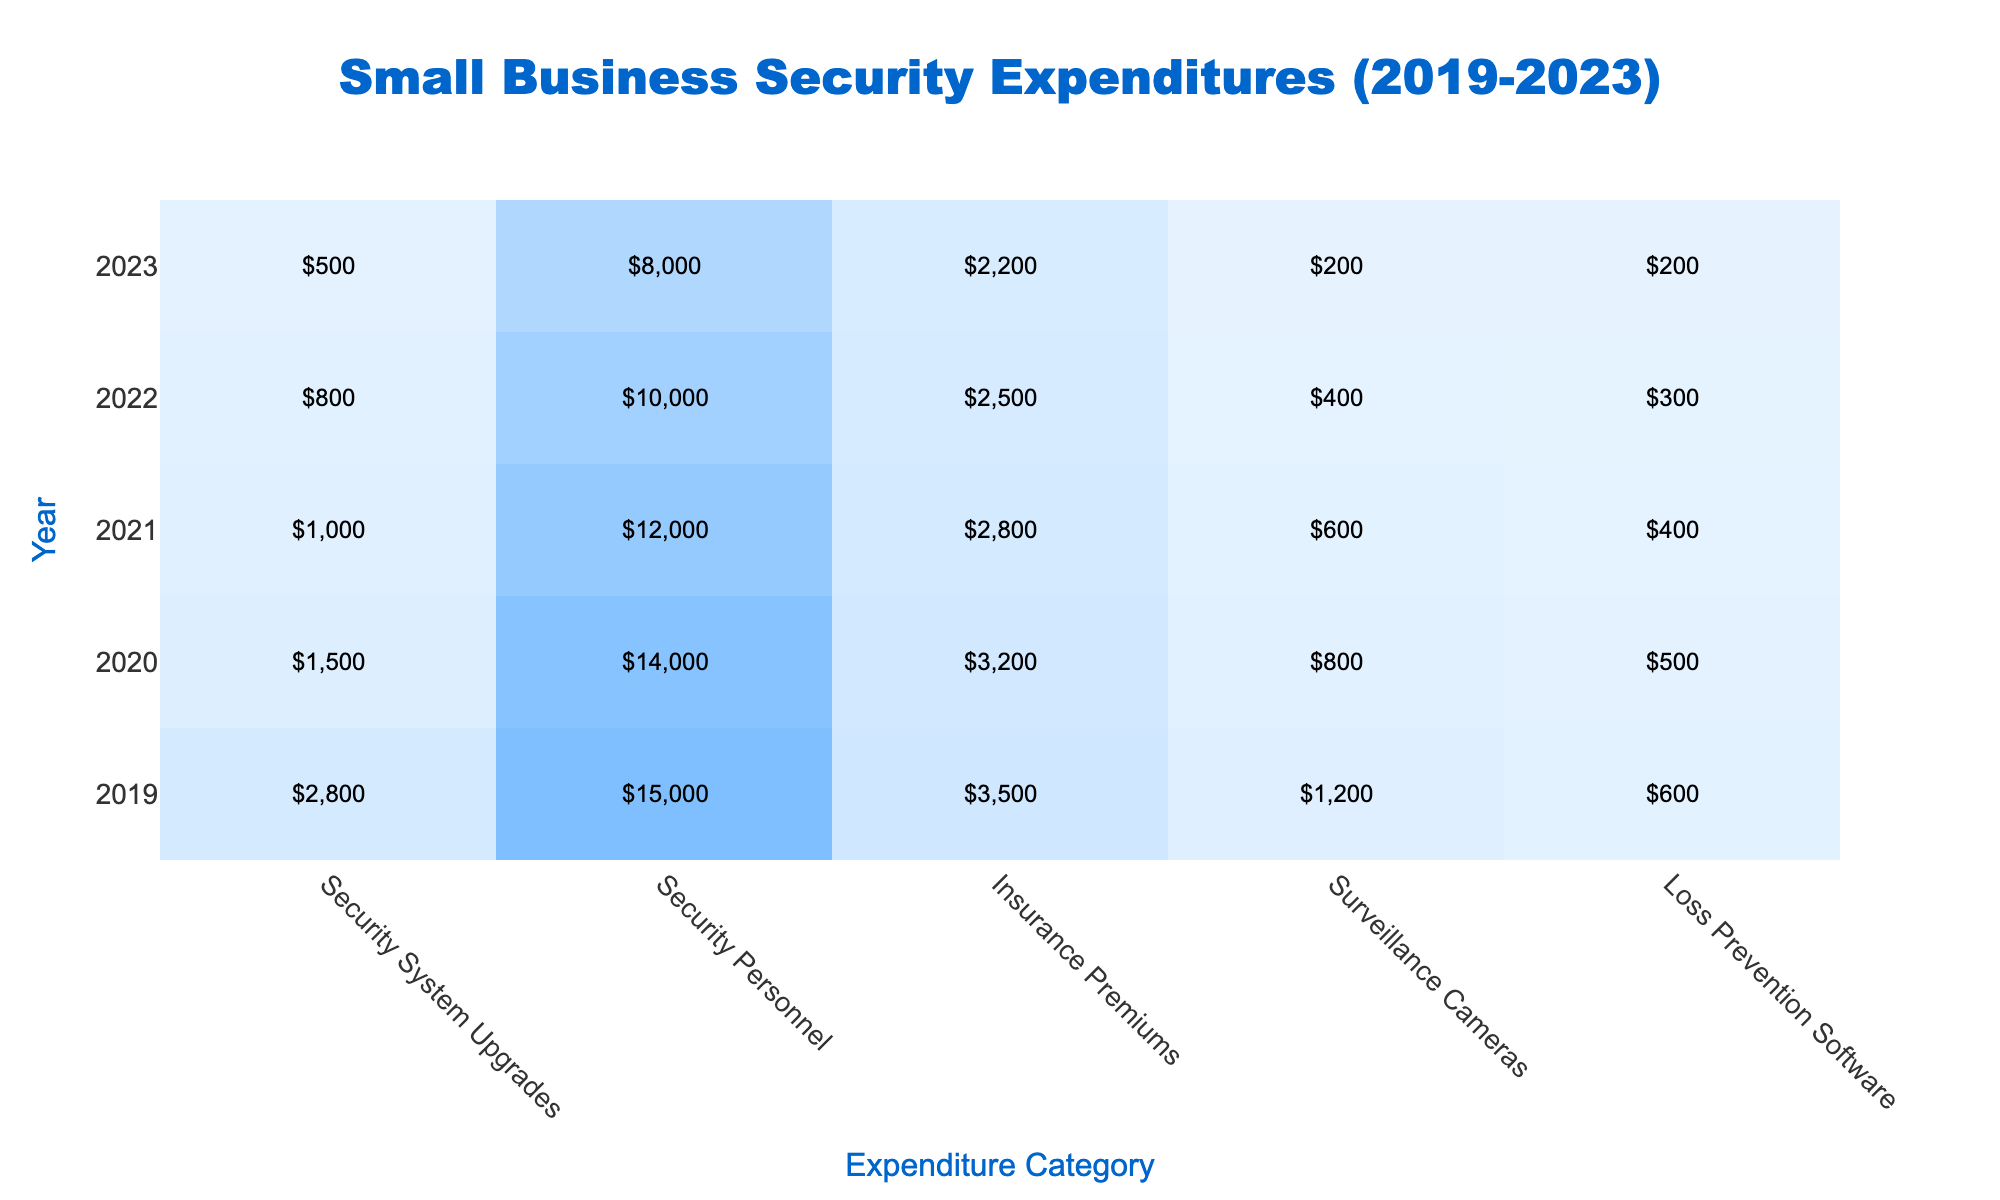What was the total expenditure on Security Personnel in 2022? To find the total expenditure on Security Personnel for 2022, look at the table under the year 2022 and the category Security Personnel, which shows an expenditure of $10,000.
Answer: $10,000 How much has the expenditure on Security System Upgrades decreased from 2019 to 2023? The expenditure on Security System Upgrades in 2019 was $2,800, and in 2023 it was $500. The decrease is calculated as $2,800 - $500 = $2,300.
Answer: $2,300 What was the insurance premium in 2021? The value for insurance premiums in 2021 is found by checking the corresponding row for that year, which shows $2,800.
Answer: $2,800 In which year did the expenditure on Loss Prevention Software reach its lowest point? Upon examining the values for Loss Prevention Software, it can be seen that the lowest expenditure was in 2023 at $200.
Answer: 2023 What is the average expenditure on Surveillance Cameras over the five years? To calculate the average, sum the expenditures from each year: $1,200 + $800 + $600 + $400 + $200 = $3,200. Then divide by the number of years (5): $3,200 / 5 = $640.
Answer: $640 Did the total expenditure on Security System Upgrades increase in 2020 compared to 2019? In 2019, the expenditure was $2,800, and in 2020 it was $1,500. Since $1,500 is less than $2,800, the expenditure decreased.
Answer: No What is the total expenditure across all categories for the year 2020? For 2020, the expenditures are: Security System Upgrades $1,500, Security Personnel $14,000, Insurance Premiums $3,200, Surveillance Cameras $800, and Loss Prevention Software $500. Adding them gives $1,500 + $14,000 + $3,200 + $800 + $500 = $20,000.
Answer: $20,000 Which expenditure category consistently decreased each year from 2019 to 2023? By observing the table, it is clear that the expenditure for Security System Upgrades decreased each year from $2,800 in 2019 to $500 in 2023.
Answer: Security System Upgrades What is the total reduction in expenditure on Security Personnel from 2019 to 2023? Security Personnel expenditure was $15,000 in 2019 and $8,000 in 2023. The reduction can be calculated as $15,000 - $8,000 = $7,000.
Answer: $7,000 Which year had the highest combined expenditure across all categories? By calculating the total expenditure for each year: 2019 = $2,800 + $15,000 + $3,500 + $1,200 + $600 = $23,100, 2020 = $1,500 + $14,000 + $3,200 + $800 + $500 = $20,000, 2021 = $1,000 + $12,000 + $2,800 + $600 + $400 = $16,800, 2022 = $800 + $10,000 + $2,500 + $400 + $300 = $14,000, and 2023 = $500 + $8,000 + $2,200 + $200 + $200 = $11,100. The highest total is $23,100 in 2019.
Answer: 2019 